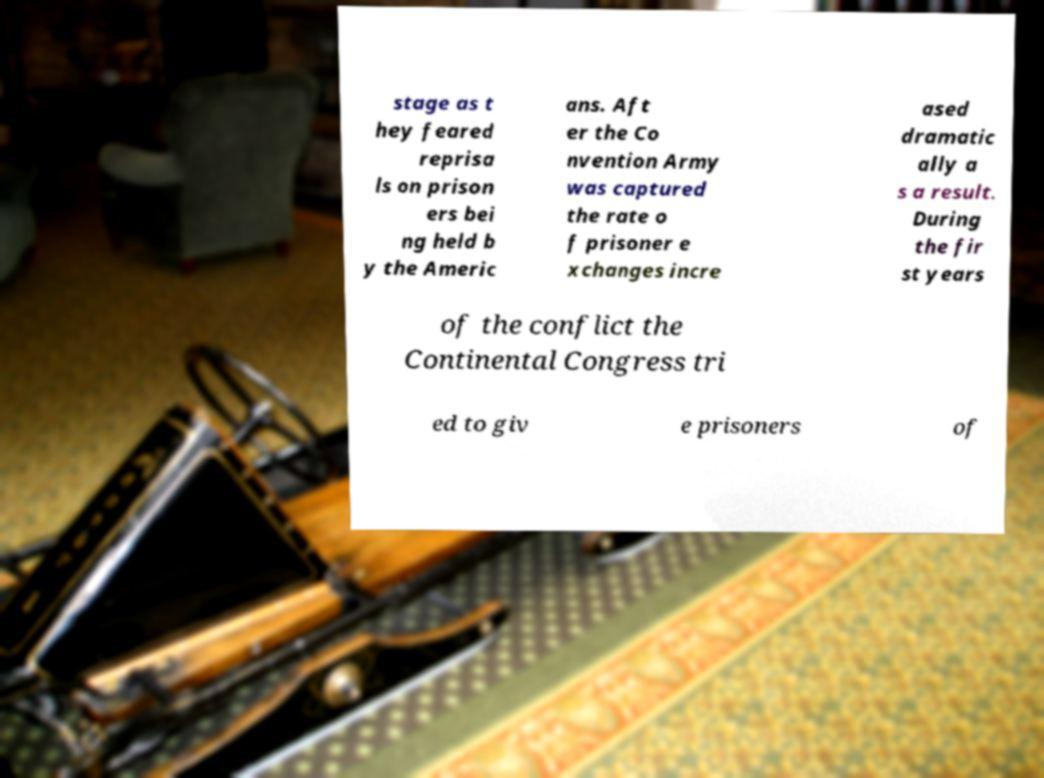What messages or text are displayed in this image? I need them in a readable, typed format. stage as t hey feared reprisa ls on prison ers bei ng held b y the Americ ans. Aft er the Co nvention Army was captured the rate o f prisoner e xchanges incre ased dramatic ally a s a result. During the fir st years of the conflict the Continental Congress tri ed to giv e prisoners of 